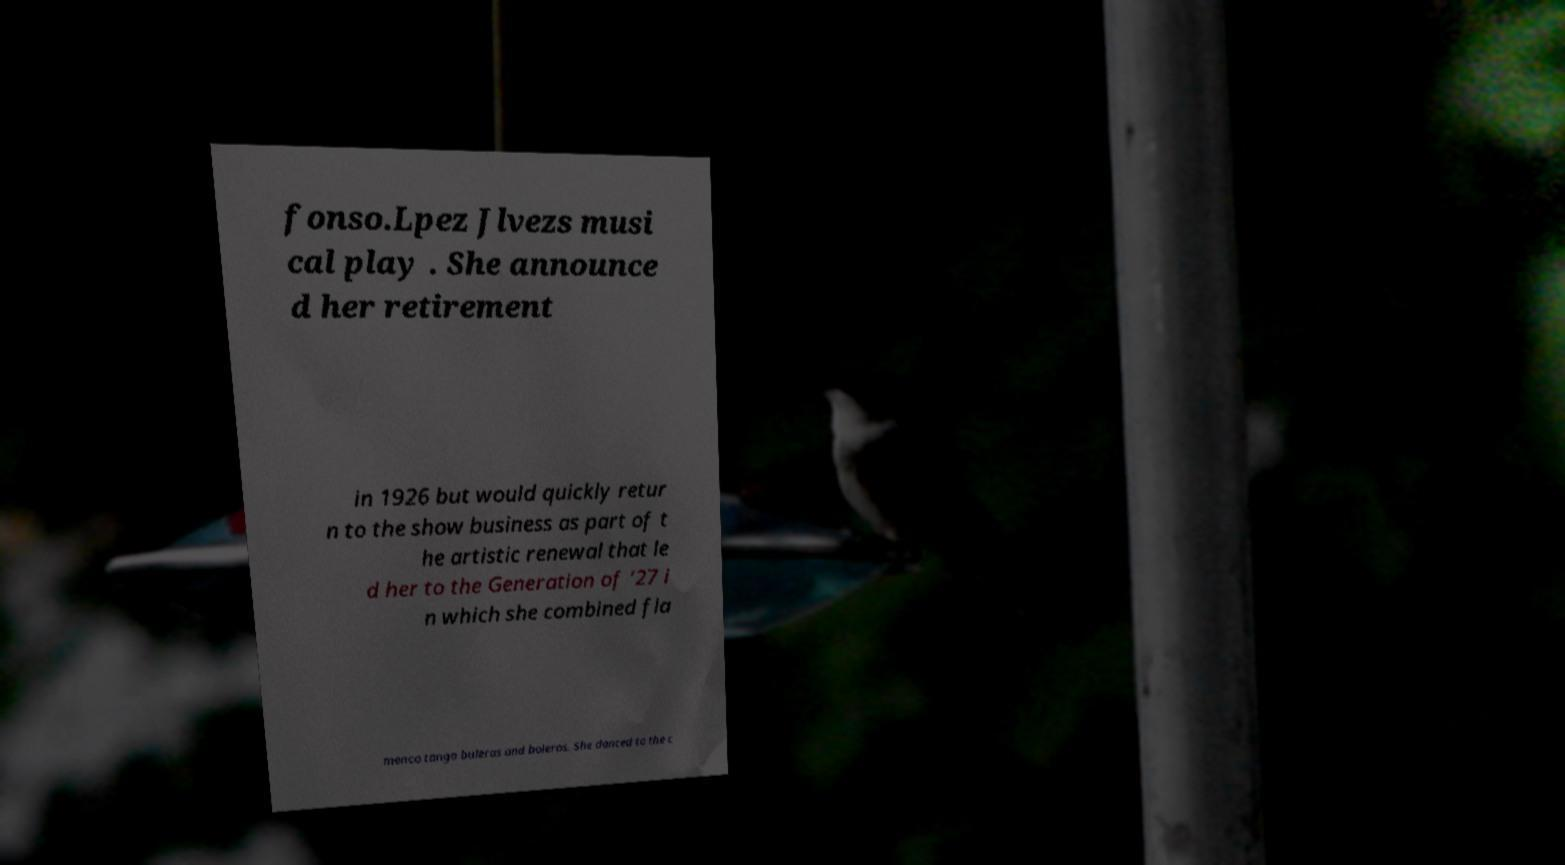There's text embedded in this image that I need extracted. Can you transcribe it verbatim? fonso.Lpez Jlvezs musi cal play . She announce d her retirement in 1926 but would quickly retur n to the show business as part of t he artistic renewal that le d her to the Generation of ‘27 i n which she combined fla menco tango buleras and boleros. She danced to the c 